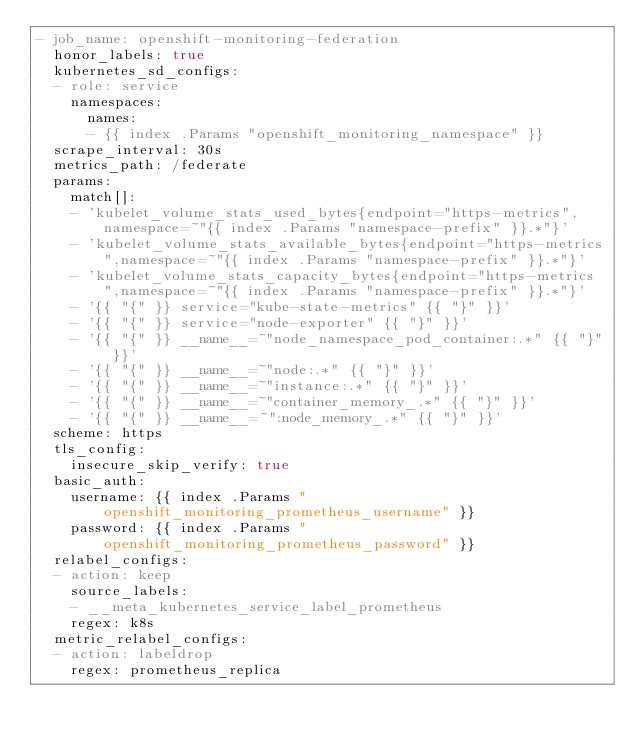Convert code to text. <code><loc_0><loc_0><loc_500><loc_500><_YAML_>- job_name: openshift-monitoring-federation
  honor_labels: true
  kubernetes_sd_configs:
  - role: service
    namespaces:
      names:
      - {{ index .Params "openshift_monitoring_namespace" }}
  scrape_interval: 30s
  metrics_path: /federate
  params:
    match[]:
    - 'kubelet_volume_stats_used_bytes{endpoint="https-metrics",namespace=~"{{ index .Params "namespace-prefix" }}.*"}'
    - 'kubelet_volume_stats_available_bytes{endpoint="https-metrics",namespace=~"{{ index .Params "namespace-prefix" }}.*"}'
    - 'kubelet_volume_stats_capacity_bytes{endpoint="https-metrics",namespace=~"{{ index .Params "namespace-prefix" }}.*"}'
    - '{{ "{" }} service="kube-state-metrics" {{ "}" }}'
    - '{{ "{" }} service="node-exporter" {{ "}" }}'
    - '{{ "{" }} __name__=~"node_namespace_pod_container:.*" {{ "}" }}'
    - '{{ "{" }} __name__=~"node:.*" {{ "}" }}'
    - '{{ "{" }} __name__=~"instance:.*" {{ "}" }}'
    - '{{ "{" }} __name__=~"container_memory_.*" {{ "}" }}'
    - '{{ "{" }} __name__=~":node_memory_.*" {{ "}" }}'
  scheme: https
  tls_config:
    insecure_skip_verify: true
  basic_auth:
    username: {{ index .Params "openshift_monitoring_prometheus_username" }}
    password: {{ index .Params "openshift_monitoring_prometheus_password" }}
  relabel_configs:
  - action: keep
    source_labels:
    - __meta_kubernetes_service_label_prometheus
    regex: k8s
  metric_relabel_configs:
  - action: labeldrop
    regex: prometheus_replica
</code> 